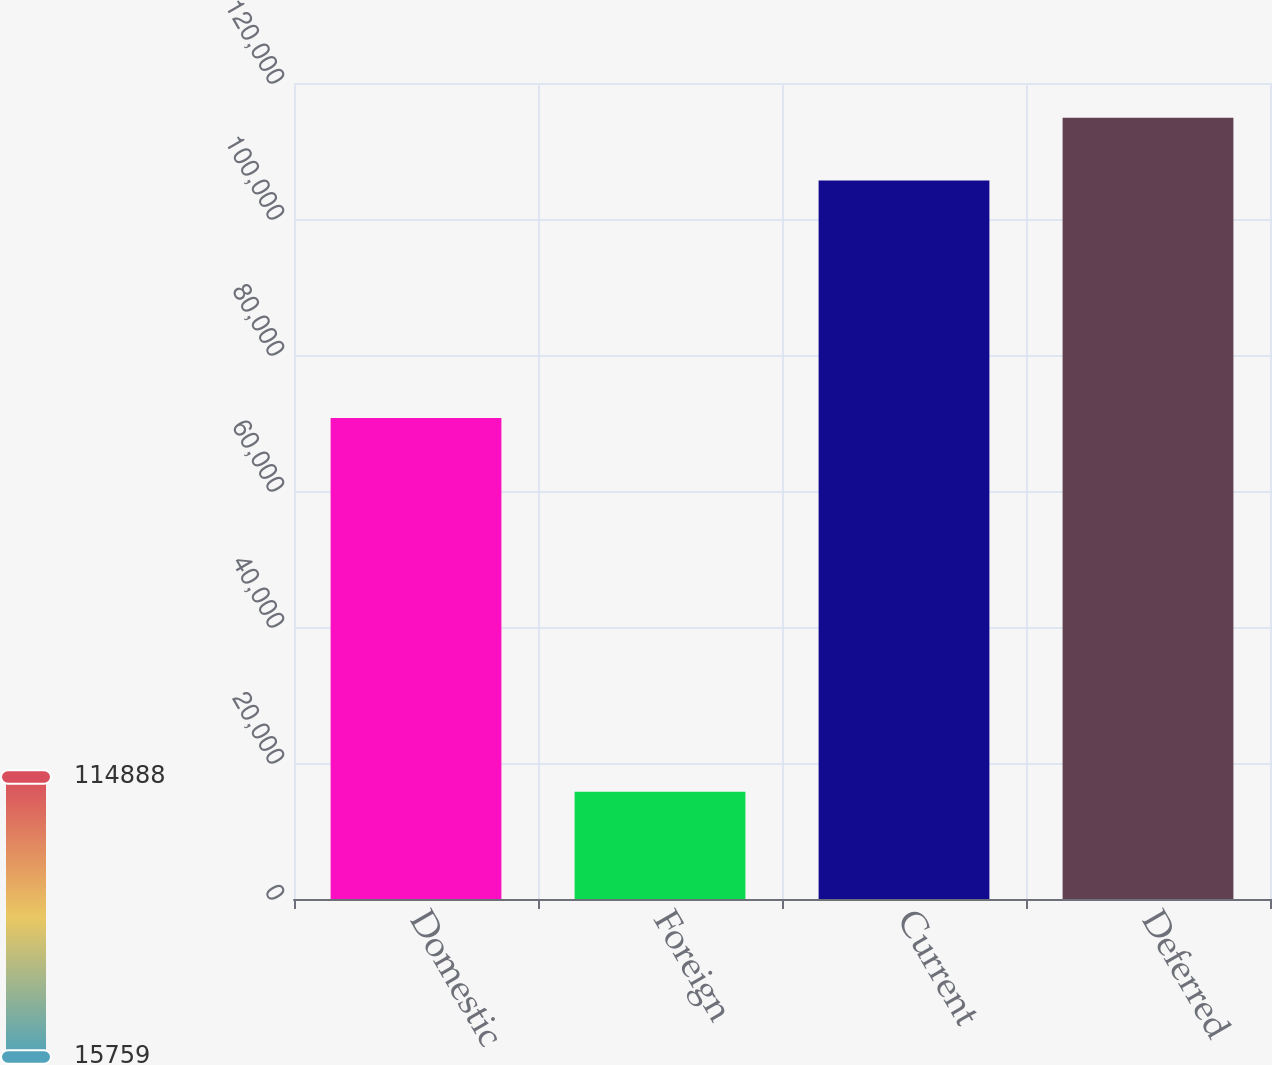Convert chart. <chart><loc_0><loc_0><loc_500><loc_500><bar_chart><fcel>Domestic<fcel>Foreign<fcel>Current<fcel>Deferred<nl><fcel>70750<fcel>15759<fcel>105664<fcel>114888<nl></chart> 